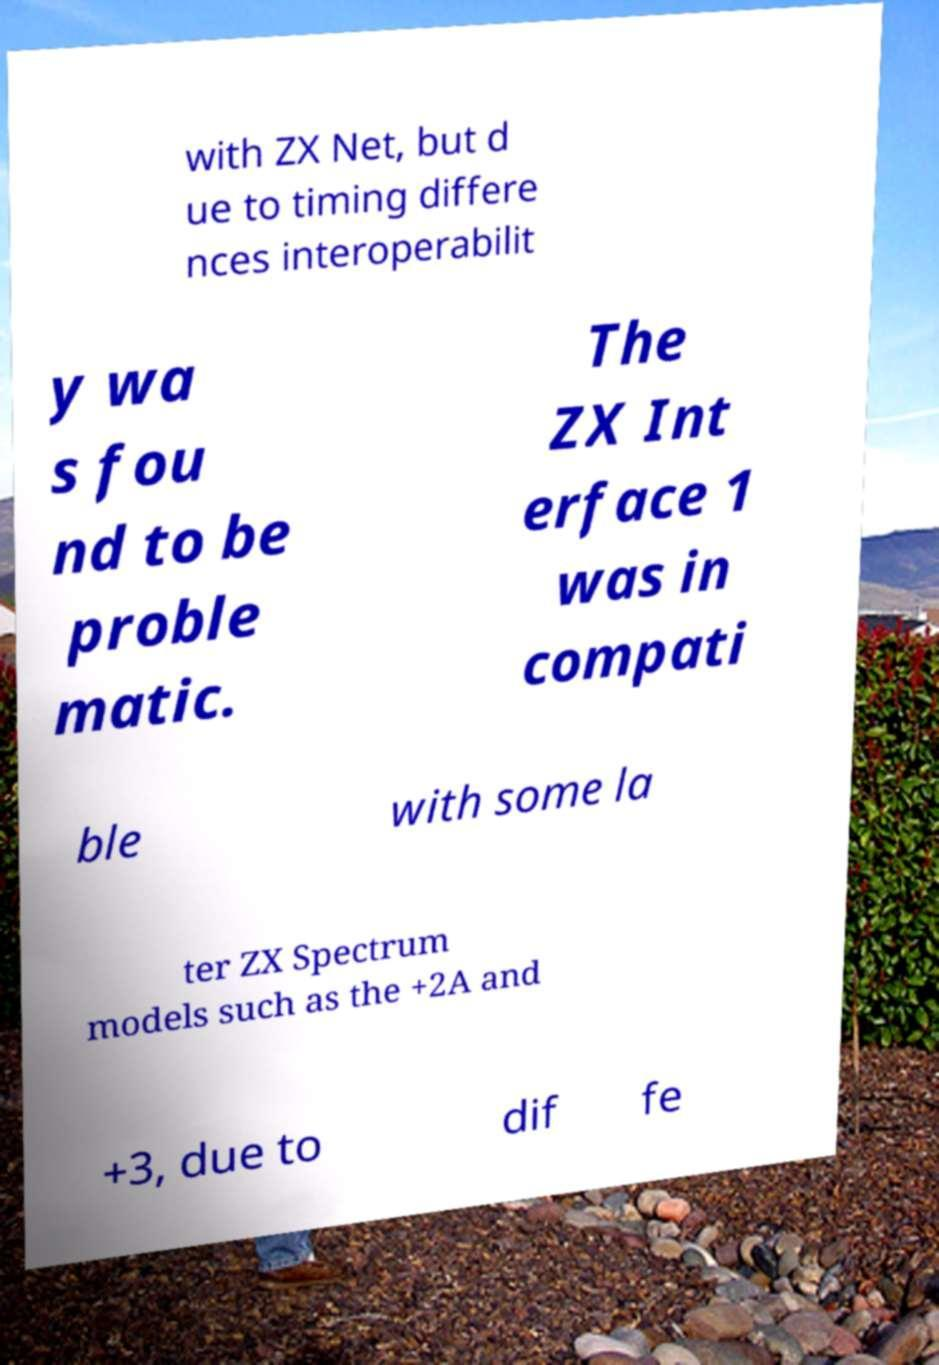I need the written content from this picture converted into text. Can you do that? with ZX Net, but d ue to timing differe nces interoperabilit y wa s fou nd to be proble matic. The ZX Int erface 1 was in compati ble with some la ter ZX Spectrum models such as the +2A and +3, due to dif fe 